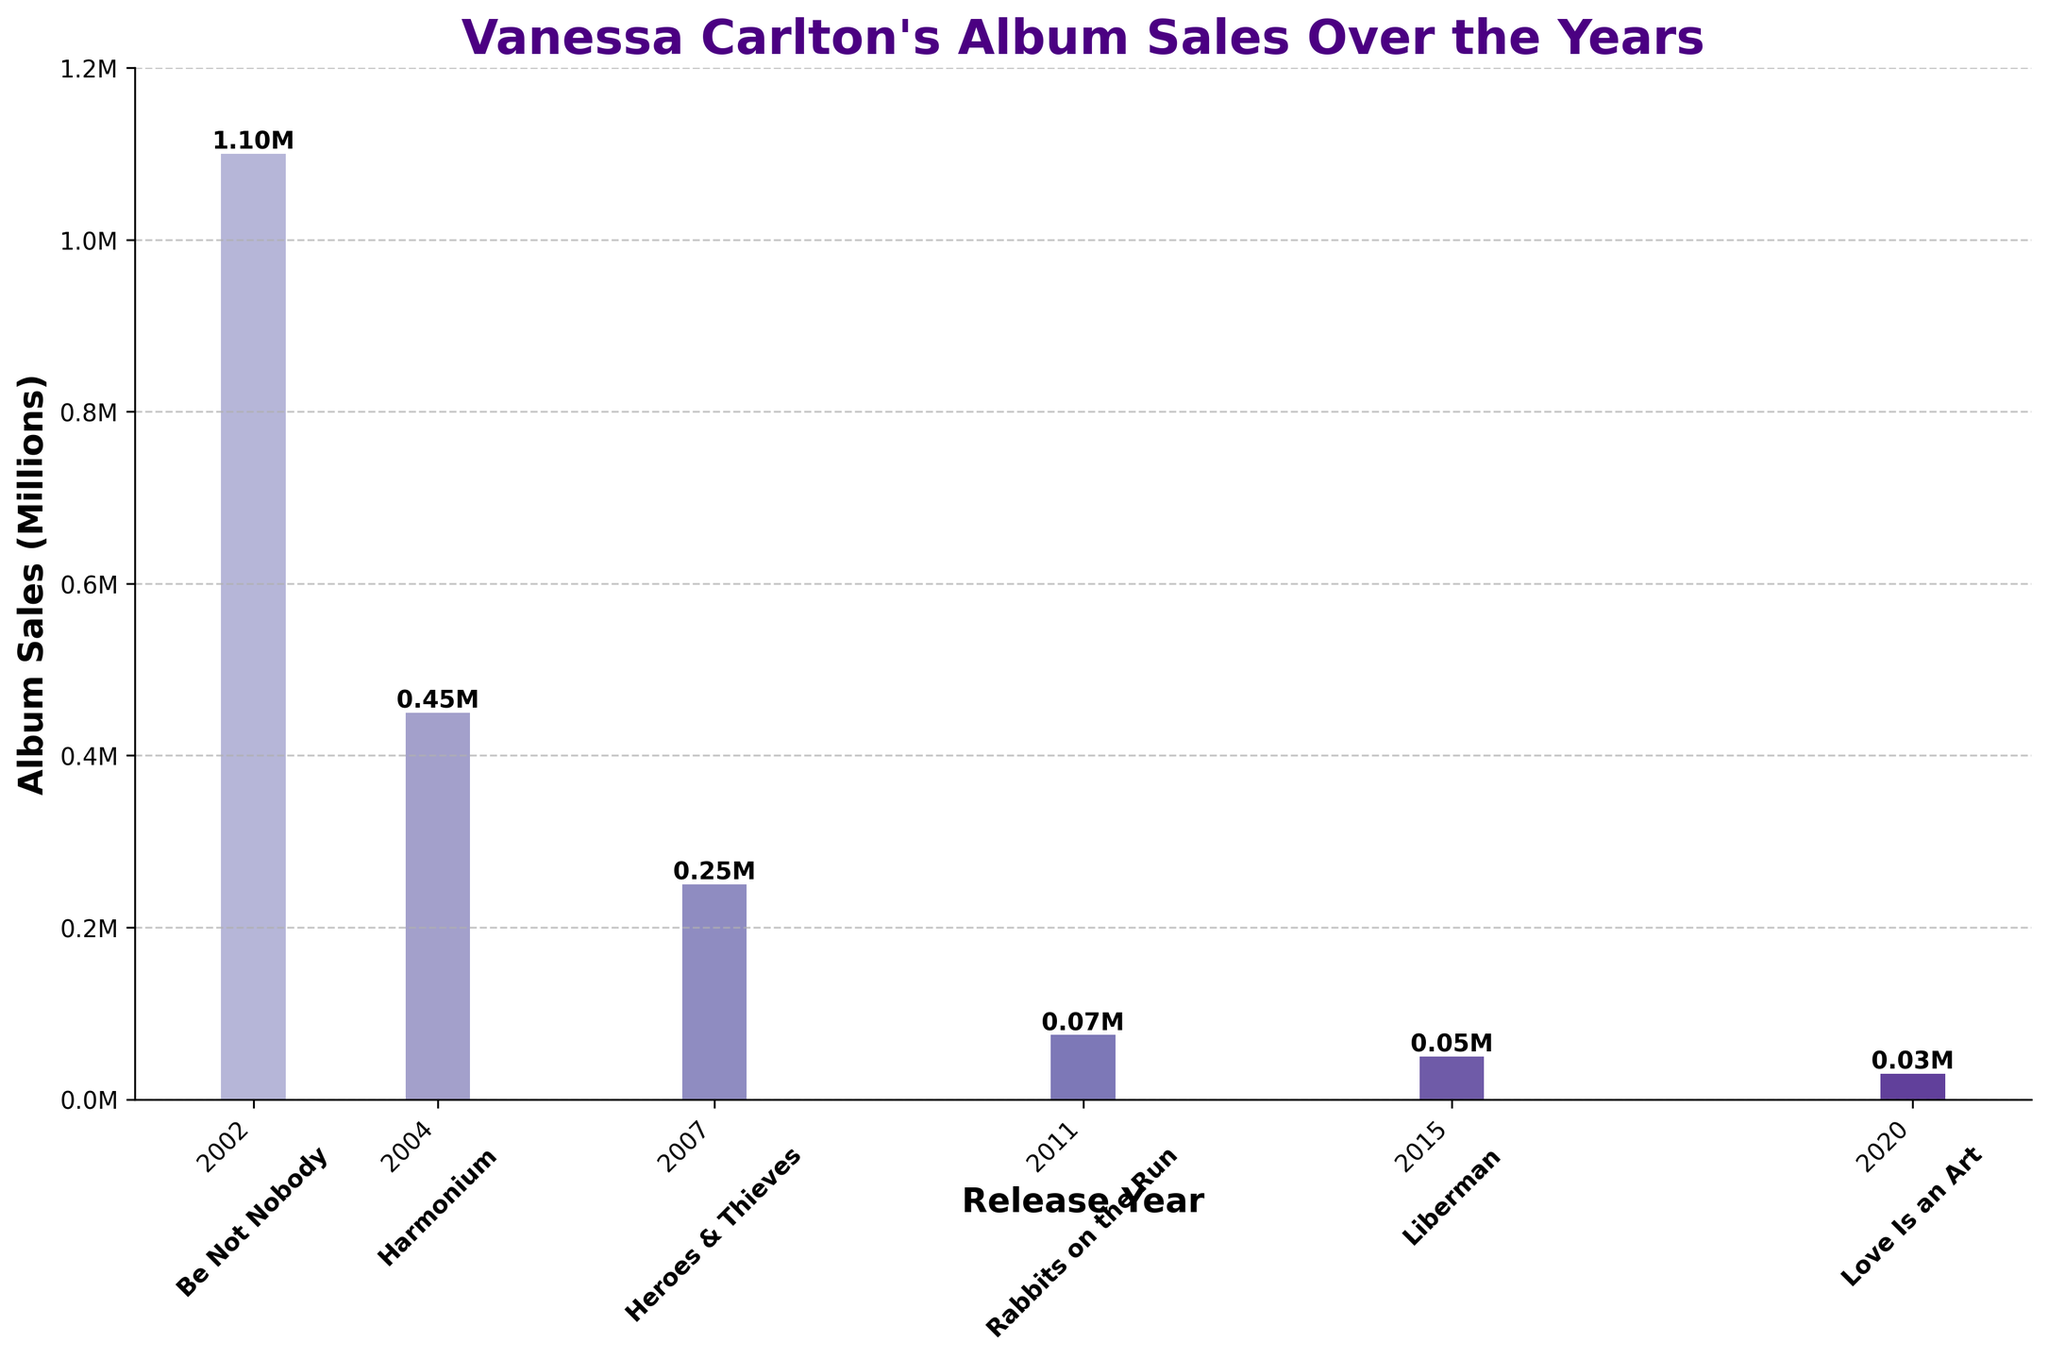How many albums did Vanessa Carlton release between 2002 and 2011? Refer to the years axis and count the bars representing albums released between 2002 and 2011.
Answer: 4 Which album had the highest sales and how much were the sales? Look for the tallest bar and read its corresponding label and height.
Answer: Be Not Nobody (1.10 million) How do the sales of "Harmonium" compare to "Love Is an Art"? Compare the heights of the bars for "Harmonium" and "Love Is an Art" on the sales axis.
Answer: Harmonium has higher sales (0.45 million) compared to Love Is an Art (0.03 million) What is the total sales of all albums combined? Add up the sales of all the bars: (1.10 + 0.45 + 0.25 + 0.075 + 0.05 + 0.03).
Answer: 1.955 million Which album released after 2007 had the lowest sales and what were those sales? Find the bars corresponding to albums released after 2007 and identify the smallest one.
Answer: Love Is an Art (0.03 million) What's the average sales per album? Sum the sales of all albums and divide by the number of albums: (1.10 + 0.45 + 0.25 + 0.075 + 0.05 + 0.03) / 6.
Answer: 0.325 million What is the change in sales between "Heroes & Thieves" and "Rabbits on the Run"? Subtract the sales of "Rabbits on the Run" from "Heroes & Thieves": 0.25 - 0.075.
Answer: 0.175 million Are there more albums released before 2010 with sales above or below 0.5 million? Count the number of bars before 2010 with heights greater than and less than 0.5 million.
Answer: More albums below 0.5 million What percentage of total sales does "Be Not Nobody" represent? Calculate (1.10 / total sales) * 100 where total sales is 1.955 million.
Answer: 56.25% What is the median sales value among all albums? List all sales values (0.03, 0.05, 0.075, 0.25, 0.45, 1.10) and find the middle value. For an even number of data points, average the two middle values.
Answer: 0.1625 million 